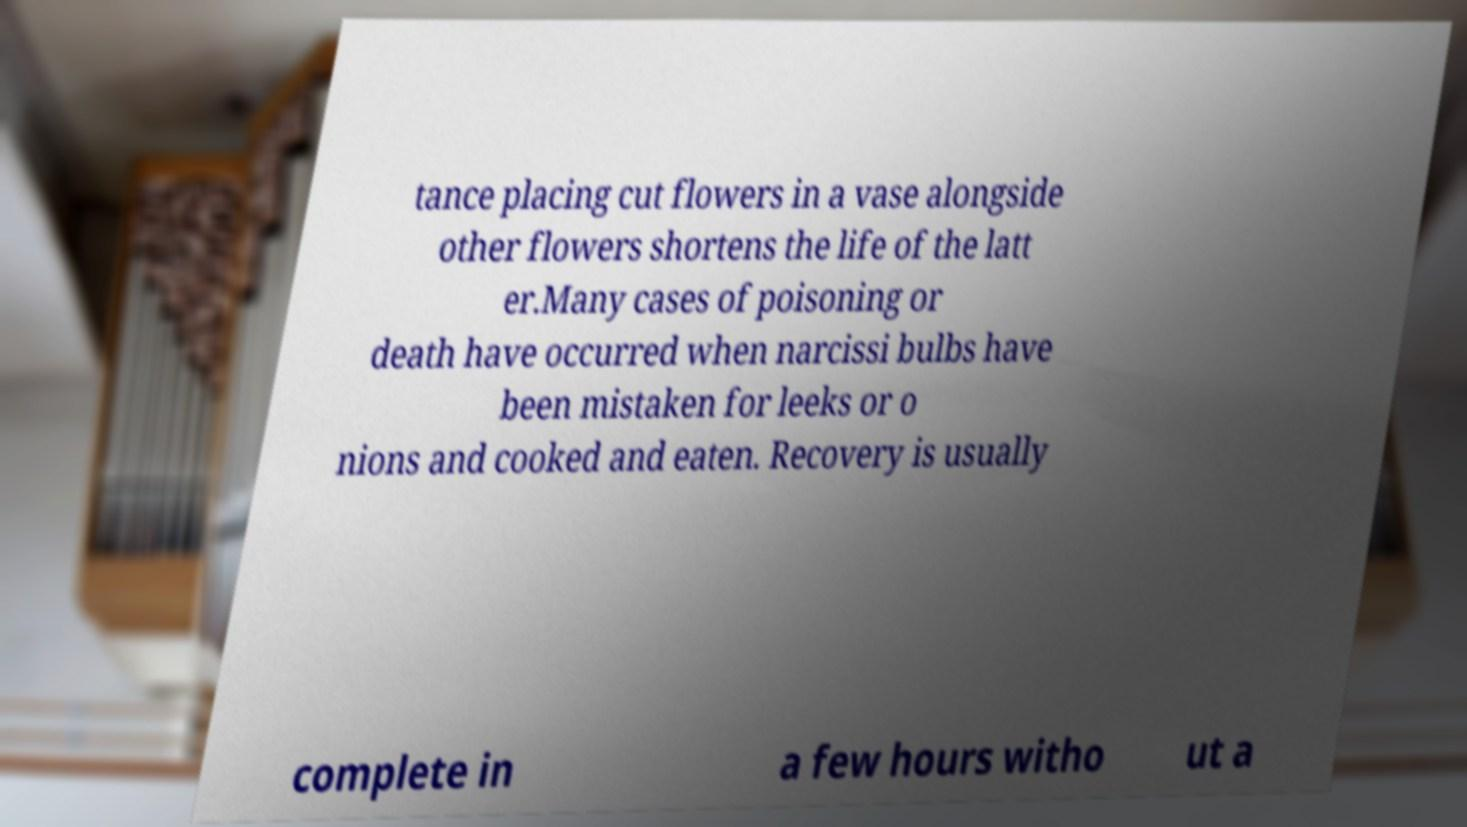Can you read and provide the text displayed in the image?This photo seems to have some interesting text. Can you extract and type it out for me? tance placing cut flowers in a vase alongside other flowers shortens the life of the latt er.Many cases of poisoning or death have occurred when narcissi bulbs have been mistaken for leeks or o nions and cooked and eaten. Recovery is usually complete in a few hours witho ut a 